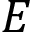Convert formula to latex. <formula><loc_0><loc_0><loc_500><loc_500>E</formula> 